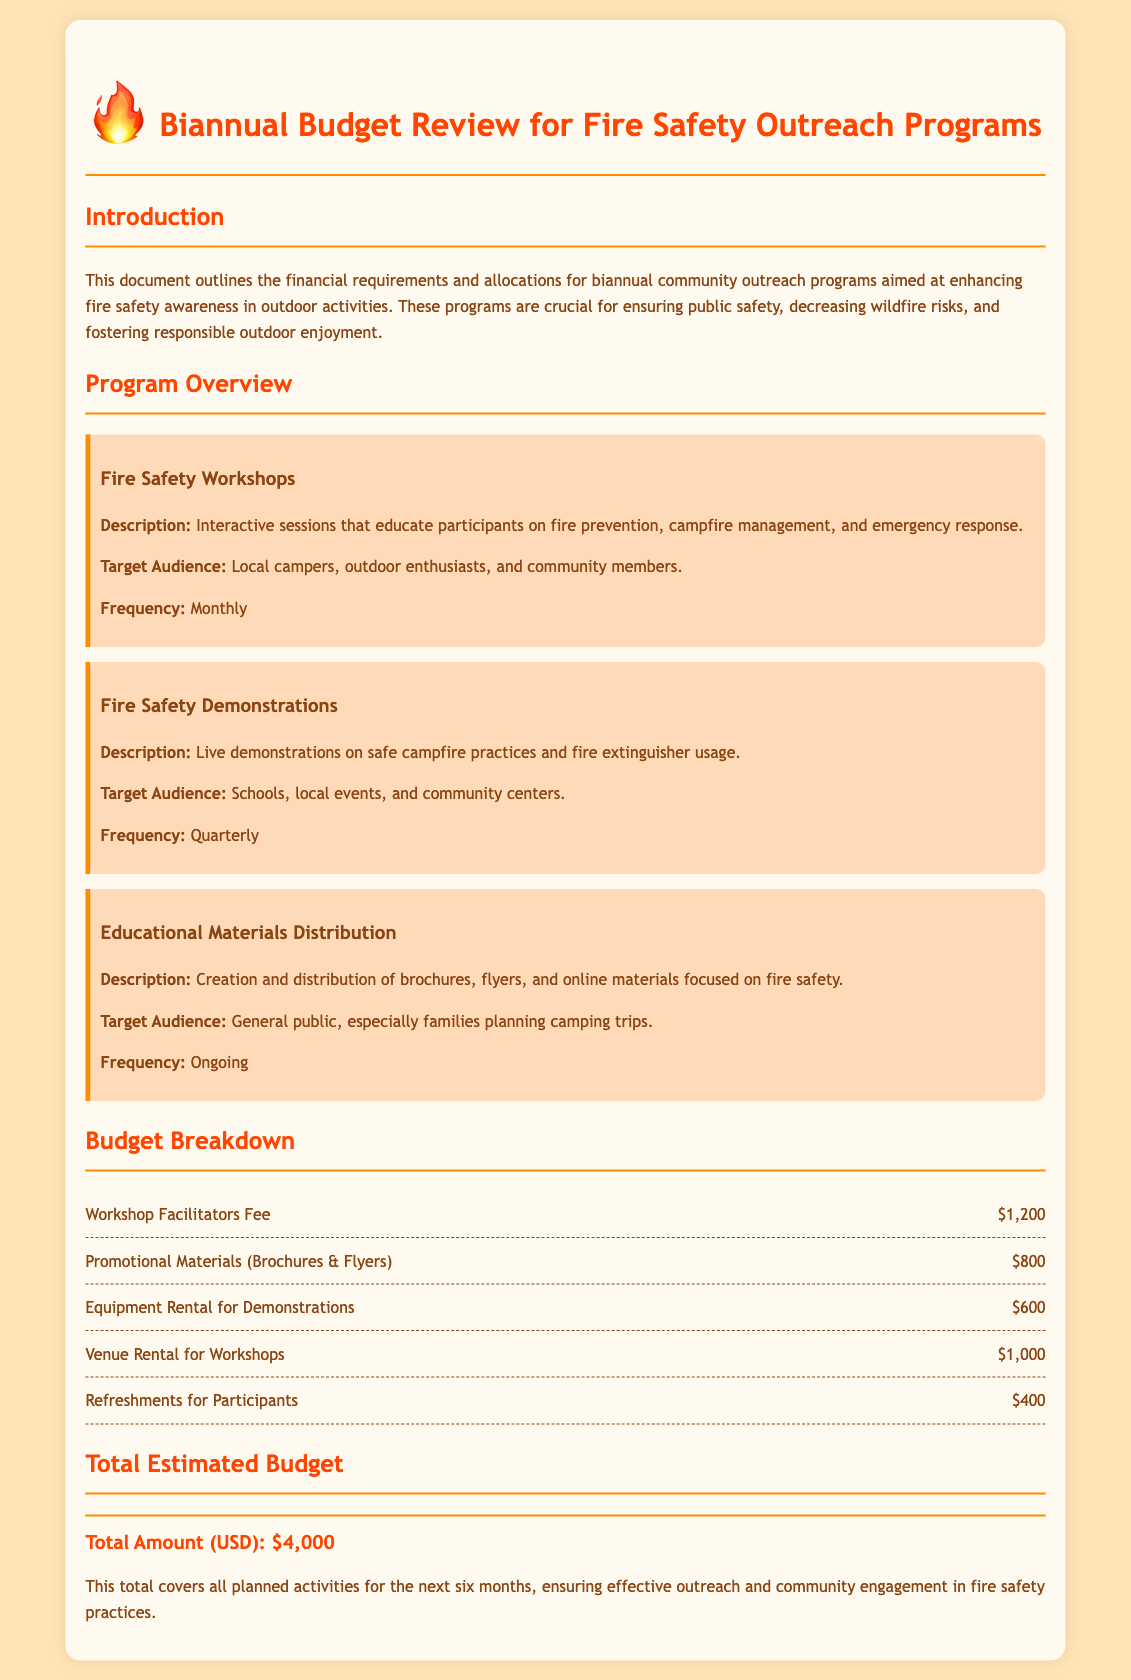What is the total estimated budget? The total estimated budget is listed under the total section of the document, which is $4,000.
Answer: $4,000 What is the frequency of Fire Safety Workshops? The document states that Fire Safety Workshops are held monthly.
Answer: Monthly What are the target audiences for Fire Safety Demonstrations? The document specifies that the target audiences include schools, local events, and community centers.
Answer: Schools, local events, and community centers What is the fee for Workshop Facilitators? The fee for Workshop Facilitators is mentioned in the budget breakdown, which is $1,200.
Answer: $1,200 How much is allocated for promotional materials? The budget item for Promotional Materials indicates an allocation of $800.
Answer: $800 What type of materials are distributed in the Educational Materials Distribution program? The document describes the materials as brochures, flyers, and online materials related to fire safety.
Answer: Brochures, flyers, and online materials What is included in the planned activities for the next six months? The planned activities include Fire Safety Workshops, Demonstrations, and Educational Materials Distribution.
Answer: Fire Safety Workshops, Demonstrations, and Educational Materials Distribution How much is budgeted for venue rental? The budget breakdown includes a venue rental cost of $1,000.
Answer: $1,000 